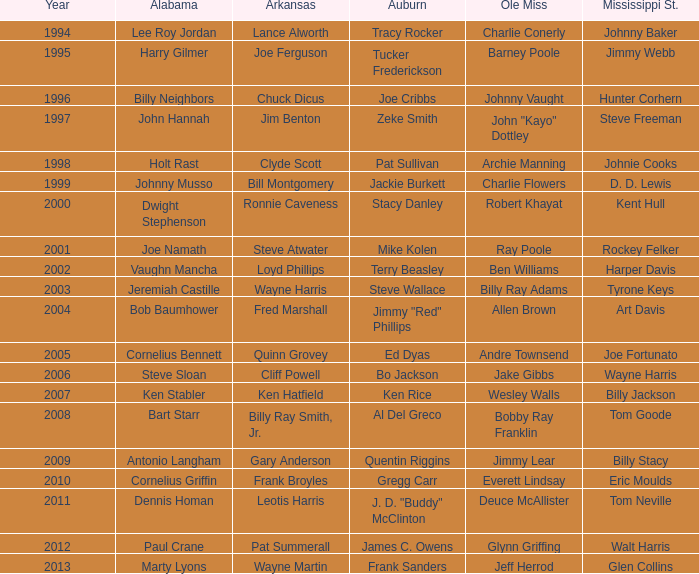Who is the Arkansas player associated with Ken Stabler? Ken Hatfield. 